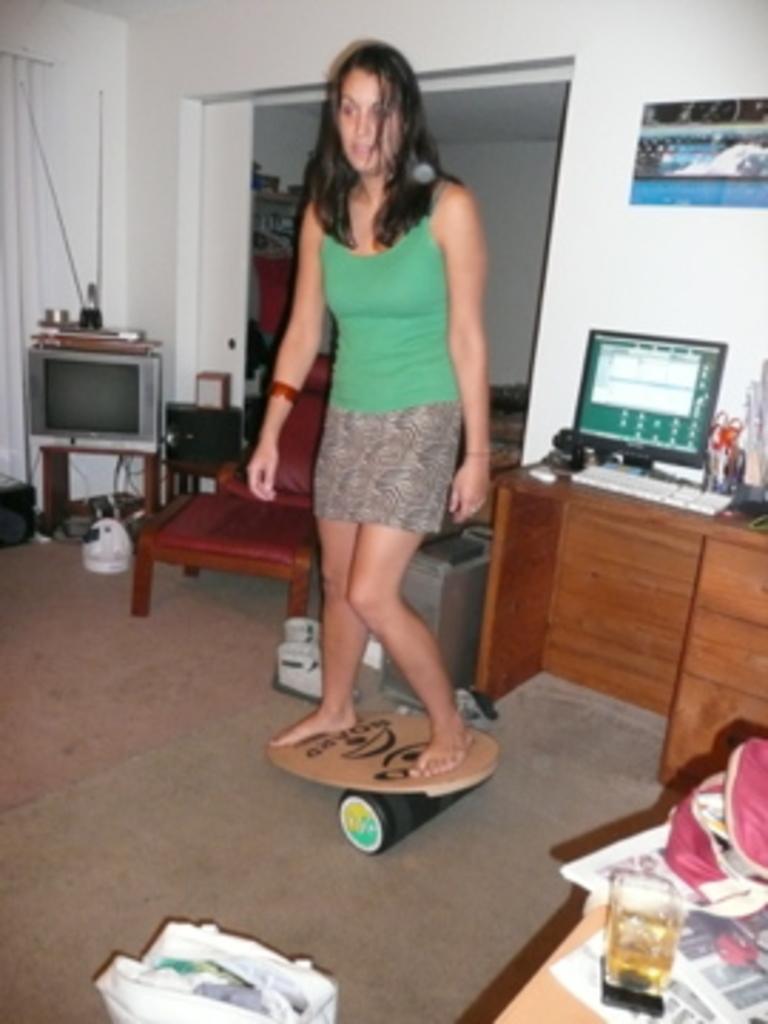Please provide a concise description of this image. In this Image In this i can see a woman wearing a green color skirt standing on a wooden plate and right side there is a table ,on the table there are papers and there is a glass kept on that, on the right side corner In this i can see a table,on the table there is a system, keyboard ,on the table there is a wall visible,And there is a photo frames attached to the wall , on the right side corner i can see a small table, on the there is a TV monitor kept on that. 